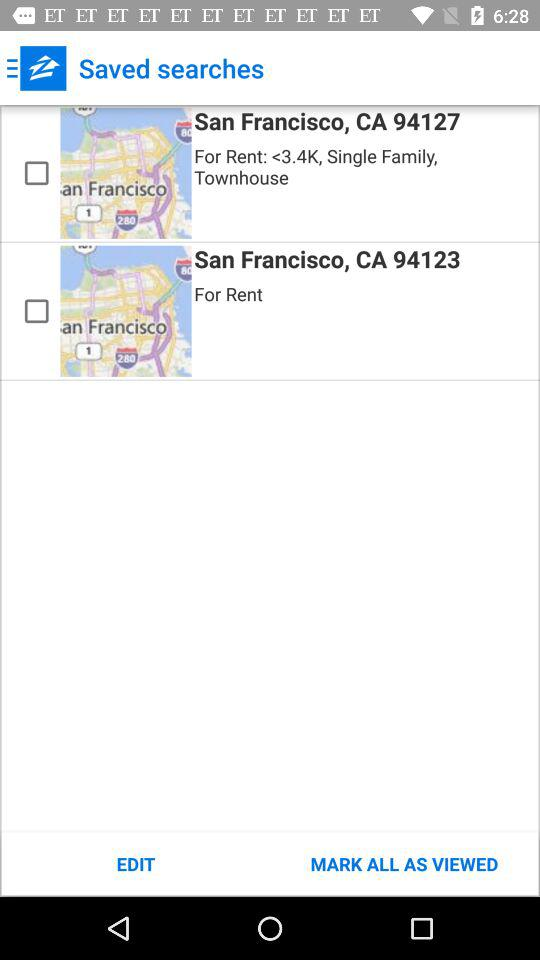How many saved searches are there?
Answer the question using a single word or phrase. 2 